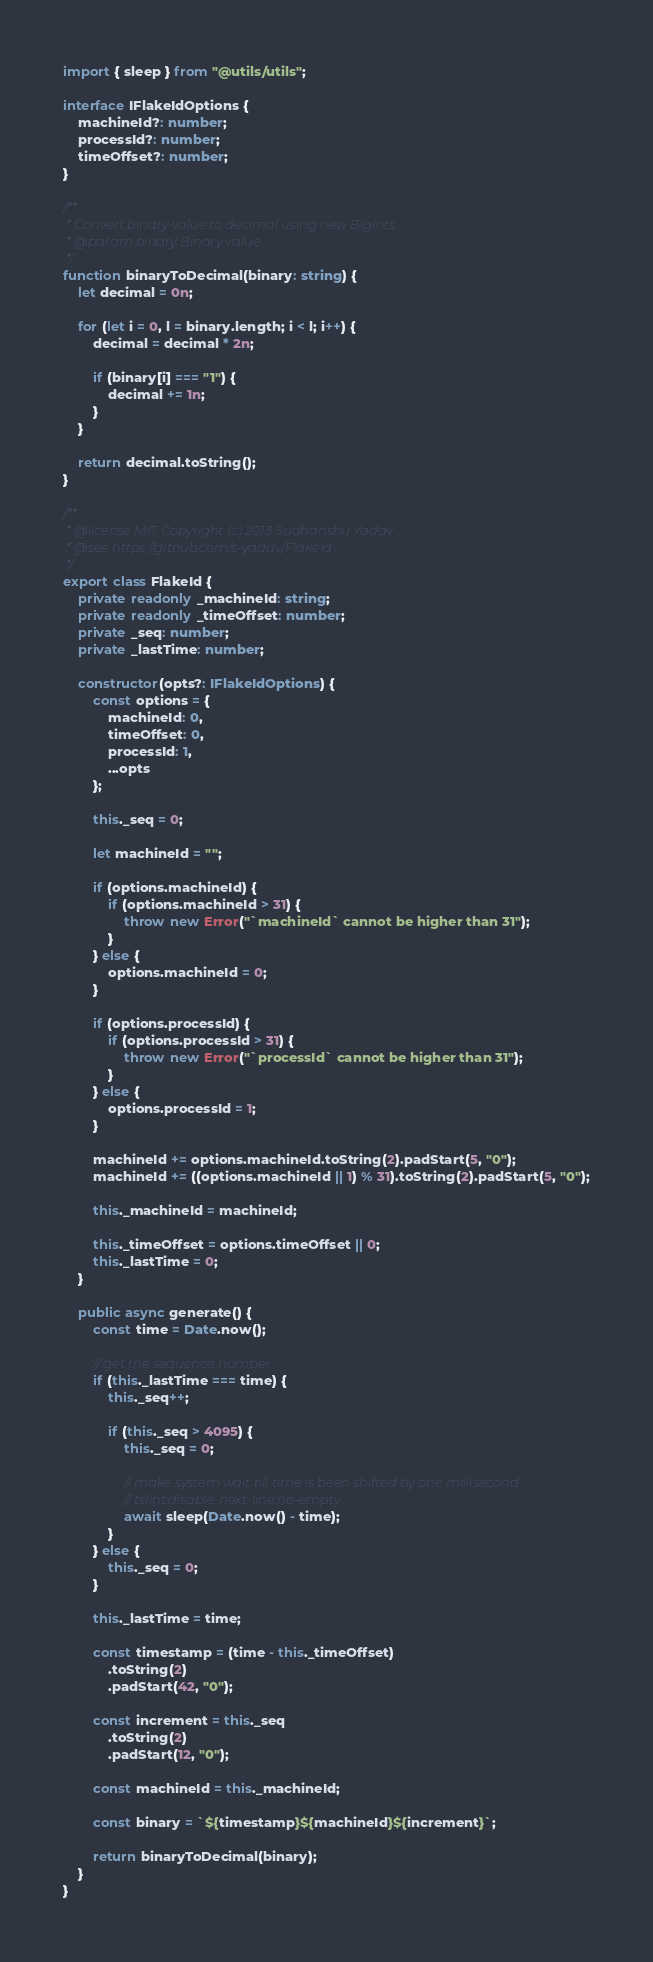Convert code to text. <code><loc_0><loc_0><loc_500><loc_500><_TypeScript_>import { sleep } from "@utils/utils";

interface IFlakeIdOptions {
	machineId?: number;
	processId?: number;
	timeOffset?: number;
}

/**
 * Convert binary value to decimal using new BigInts
 * @param binary Binary value
 */
function binaryToDecimal(binary: string) {
	let decimal = 0n;

	for (let i = 0, l = binary.length; i < l; i++) {
		decimal = decimal * 2n;
		
		if (binary[i] === "1") {
			decimal += 1n;
		}
	}

	return decimal.toString();
}

/**
 * @license MIT Copyright (c) 2013 Sudhanshu Yadav
 * @see https://github.com/s-yadav/FlakeId
 */
export class FlakeId {
	private readonly _machineId: string;
	private readonly _timeOffset: number;
	private _seq: number;
	private _lastTime: number;

	constructor(opts?: IFlakeIdOptions) {
		const options = {
			machineId: 0,
			timeOffset: 0,
			processId: 1,
			...opts
		};

		this._seq = 0;

		let machineId = "";

		if (options.machineId) {
			if (options.machineId > 31) {
				throw new Error("`machineId` cannot be higher than 31");
			}
		} else {
			options.machineId = 0;
		}

		if (options.processId) {
			if (options.processId > 31) {
				throw new Error("`processId` cannot be higher than 31");
			}
		} else {
			options.processId = 1;
		}

		machineId += options.machineId.toString(2).padStart(5, "0");
		machineId += ((options.machineId || 1) % 31).toString(2).padStart(5, "0");

		this._machineId = machineId;

		this._timeOffset = options.timeOffset || 0;
		this._lastTime = 0;
	}

	public async generate() {
		const time = Date.now();

		// get the sequence number
		if (this._lastTime === time) {
			this._seq++;

			if (this._seq > 4095) {
				this._seq = 0;

				// make system wait till time is been shifted by one millisecond
				// tslint:disable-next-line:no-empty
				await sleep(Date.now() - time);
			}
		} else {
			this._seq = 0;
		}

		this._lastTime = time;

		const timestamp = (time - this._timeOffset)
			.toString(2)
			.padStart(42, "0");

		const increment = this._seq
			.toString(2)
			.padStart(12, "0");

		const machineId = this._machineId;

		const binary = `${timestamp}${machineId}${increment}`;

		return binaryToDecimal(binary);
	}
}

</code> 